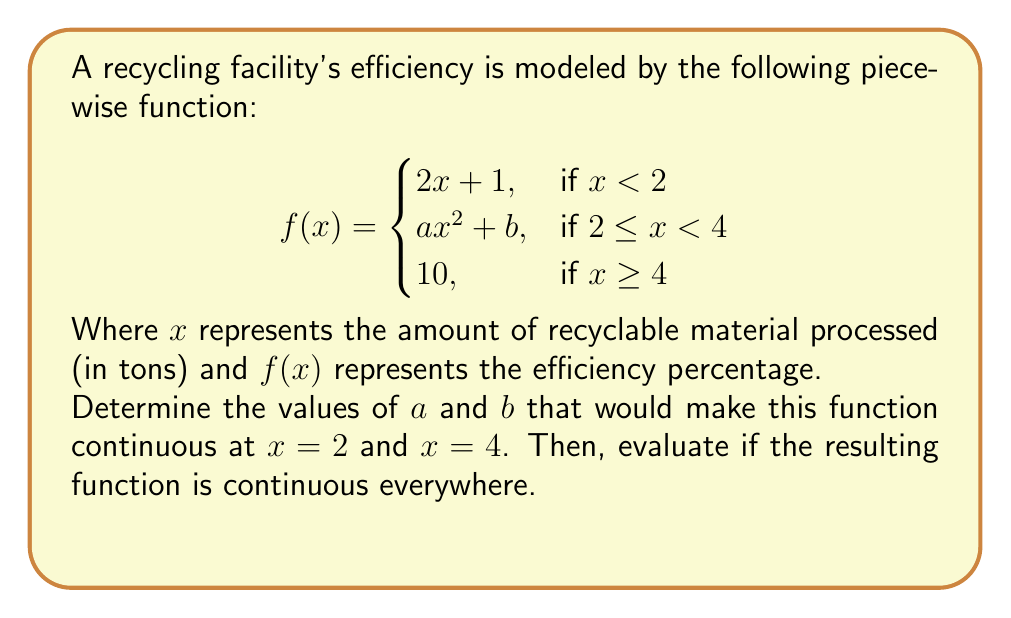Give your solution to this math problem. To determine the continuity of the piecewise function, we need to ensure that the function is continuous at the transition points $x = 2$ and $x = 4$. Let's solve this step by step:

1) For continuity at $x = 2$:
   The left-hand limit must equal the right-hand limit.
   $$\lim_{x \to 2^-} f(x) = \lim_{x \to 2^+} f(x)$$
   $$2(2) + 1 = a(2)^2 + b$$
   $$5 = 4a + b \quad \text{(Equation 1)}$$

2) For continuity at $x = 4$:
   $$\lim_{x \to 4^-} f(x) = \lim_{x \to 4^+} f(x)$$
   $$a(4)^2 + b = 10$$
   $$16a + b = 10 \quad \text{(Equation 2)}$$

3) Now we have a system of two equations with two unknowns:
   Equation 1: $5 = 4a + b$
   Equation 2: $16a + b = 10$

4) Subtracting Equation 1 from Equation 2:
   $$12a = 5$$
   $$a = \frac{5}{12} = 0.416666...$$

5) Substituting this value of $a$ into Equation 1:
   $$5 = 4(\frac{5}{12}) + b$$
   $$5 = \frac{20}{12} + b$$
   $$b = 5 - \frac{20}{12} = \frac{40}{12} = 3.333333...$$

6) Now that we have $a$ and $b$, let's check if the function is continuous everywhere:
   - It's continuous for $x < 2$ (linear function)
   - It's continuous for $2 \leq x < 4$ (quadratic function)
   - It's continuous for $x \geq 4$ (constant function)
   - We've ensured continuity at $x = 2$ and $x = 4$

Therefore, with these values of $a$ and $b$, the function is continuous everywhere.
Answer: $a = \frac{5}{12}, b = \frac{40}{12}$; The function is continuous everywhere. 